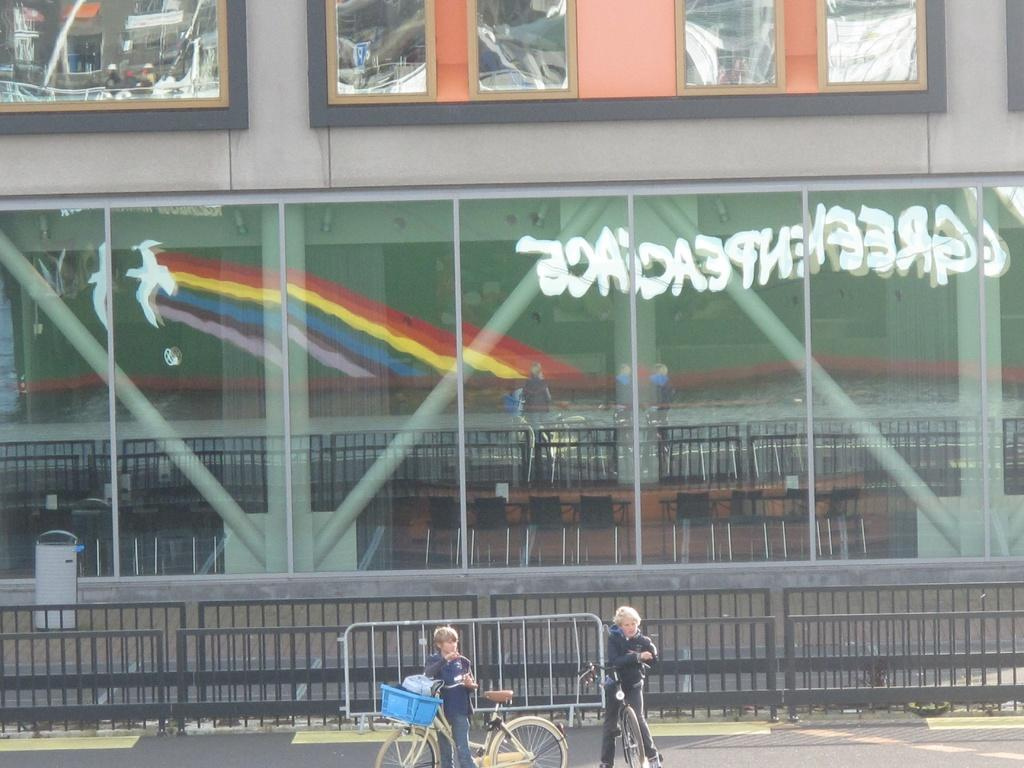<image>
Share a concise interpretation of the image provided. An outdoor view looking into some sort of convention venue with "Greenpeace" on the reverse side of the glass. 